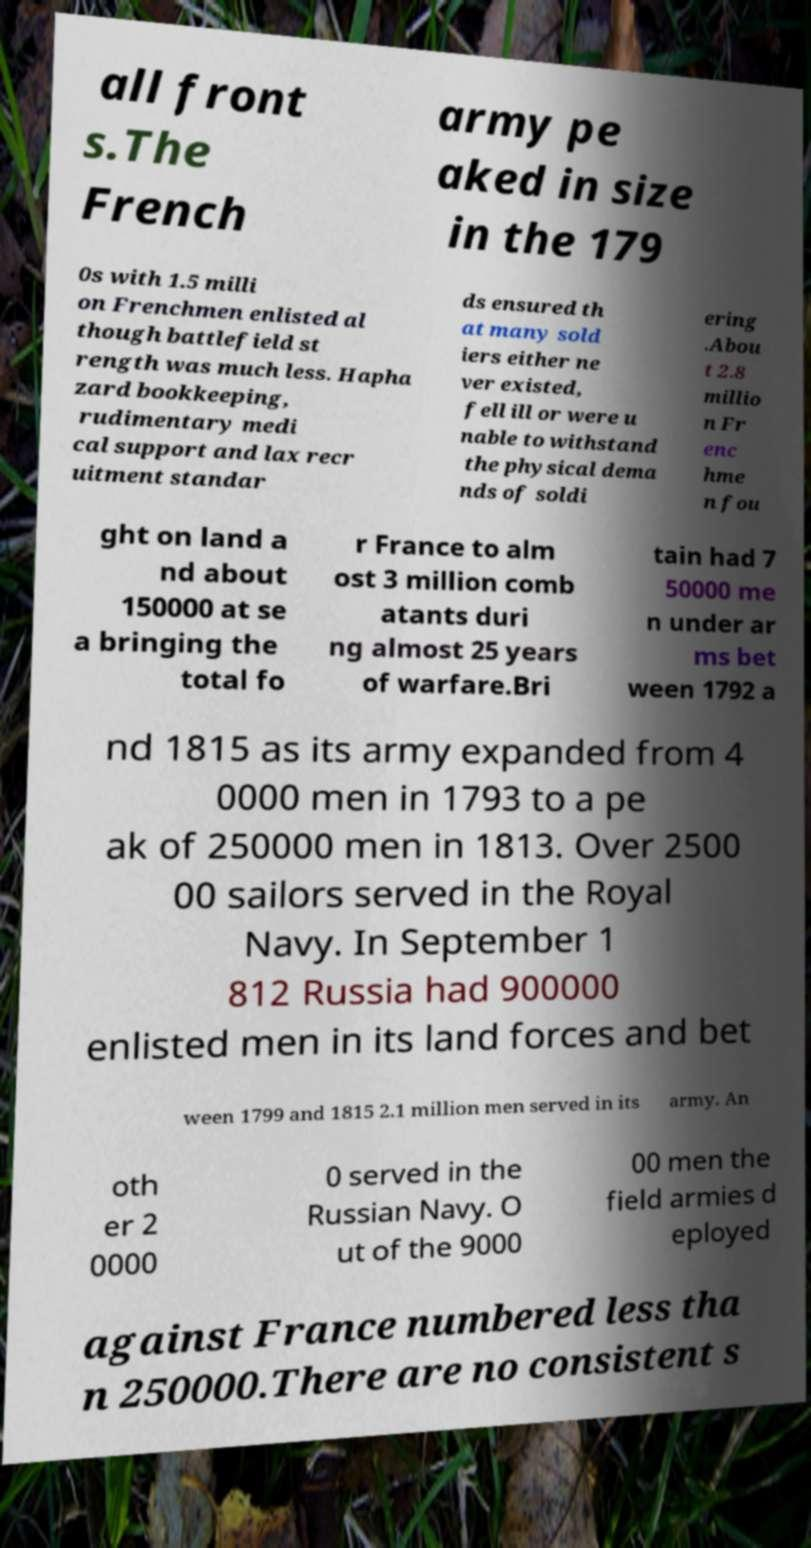What messages or text are displayed in this image? I need them in a readable, typed format. all front s.The French army pe aked in size in the 179 0s with 1.5 milli on Frenchmen enlisted al though battlefield st rength was much less. Hapha zard bookkeeping, rudimentary medi cal support and lax recr uitment standar ds ensured th at many sold iers either ne ver existed, fell ill or were u nable to withstand the physical dema nds of soldi ering .Abou t 2.8 millio n Fr enc hme n fou ght on land a nd about 150000 at se a bringing the total fo r France to alm ost 3 million comb atants duri ng almost 25 years of warfare.Bri tain had 7 50000 me n under ar ms bet ween 1792 a nd 1815 as its army expanded from 4 0000 men in 1793 to a pe ak of 250000 men in 1813. Over 2500 00 sailors served in the Royal Navy. In September 1 812 Russia had 900000 enlisted men in its land forces and bet ween 1799 and 1815 2.1 million men served in its army. An oth er 2 0000 0 served in the Russian Navy. O ut of the 9000 00 men the field armies d eployed against France numbered less tha n 250000.There are no consistent s 